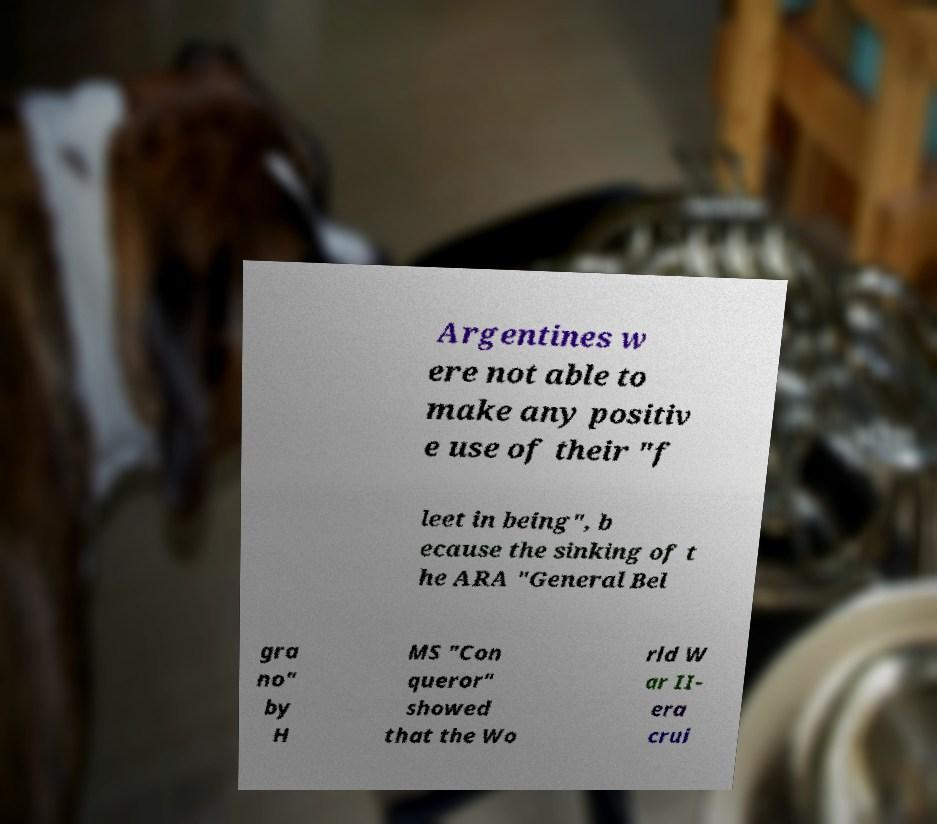Please read and relay the text visible in this image. What does it say? Argentines w ere not able to make any positiv e use of their "f leet in being", b ecause the sinking of t he ARA "General Bel gra no" by H MS "Con queror" showed that the Wo rld W ar II- era crui 